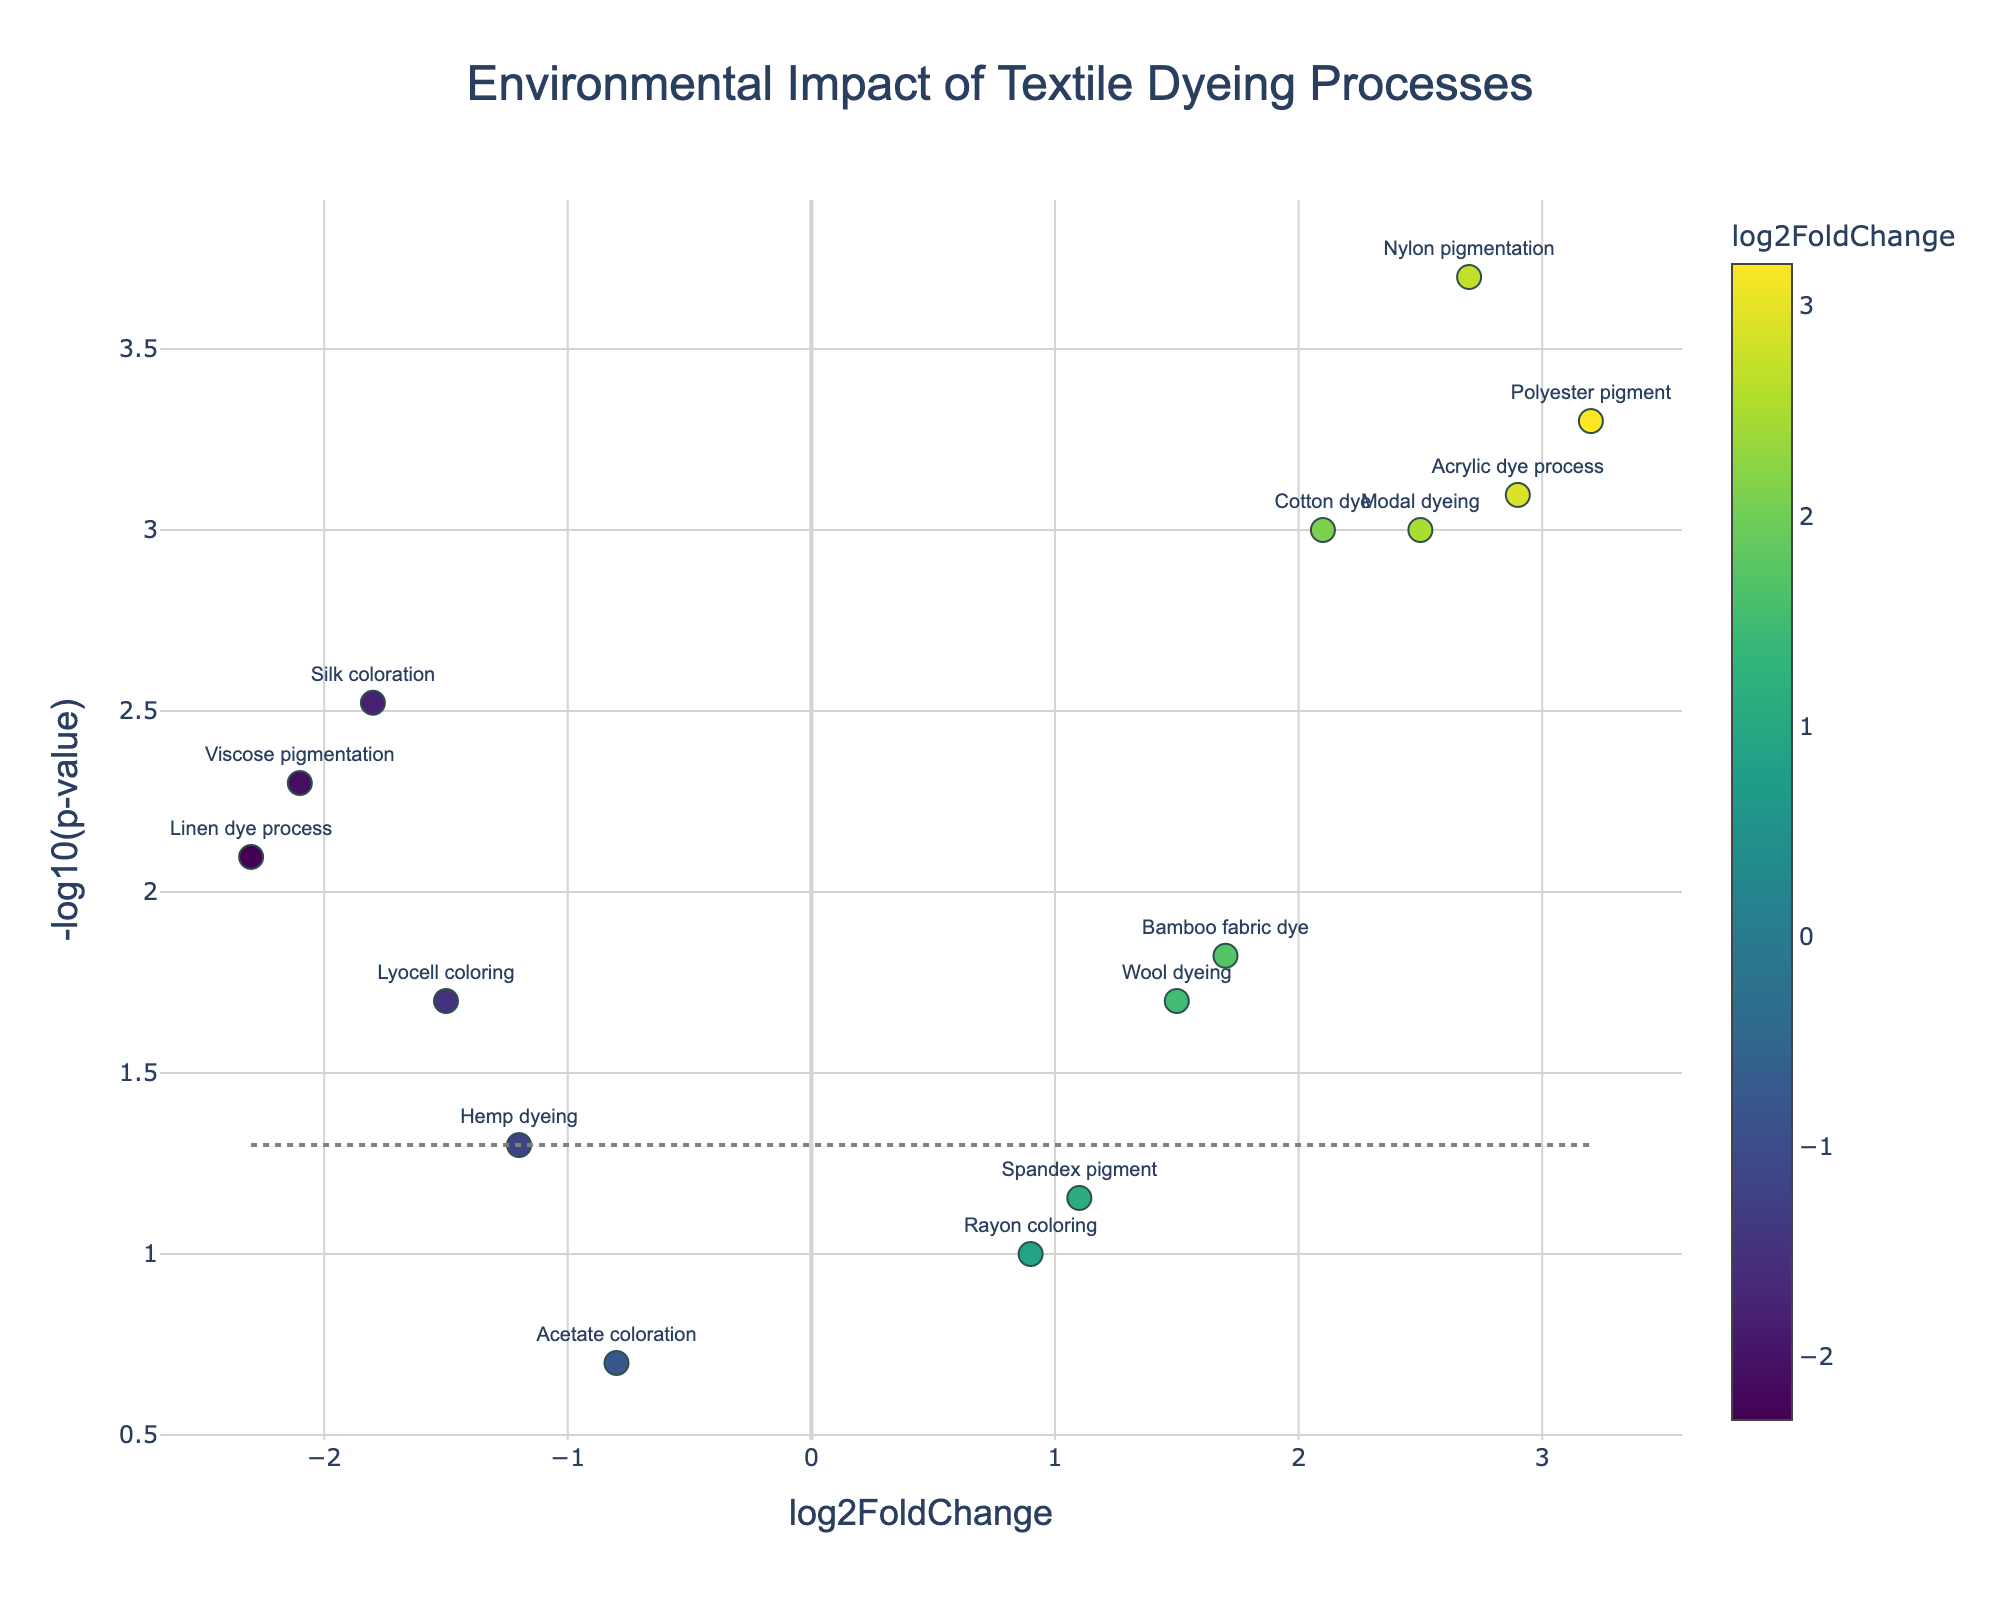What is the title of the plot? The title of the plot is prominently shown at the top and reads "Environmental Impact of Textile Dyeing Processes".
Answer: Environmental Impact of Textile Dyeing Processes Which textile dyeing process has the highest log2FoldChange? To determine the highest log2FoldChange, look for the data point furthest to the right on the x-axis as this axis represents log2FoldChange. This point is labeled "Polyester pigment".
Answer: Polyester pigment Which textile dyeing process has the lowest p-value? The p-value can be inferred from the y-axis, which represents -log10(p-value). The higher the y-value, the lower the p-value. Therefore, the highest y-value represents the lowest p-value and it corresponds to "Nylon pigmentation".
Answer: Nylon pigmentation How many textile dyeing processes have a p-value lower than 0.05? The horizontal line in the plot represents the threshold for a p-value of 0.05. We count the number of points above this line. There are nine points above this line.
Answer: 9 Which textile dyeing process has the lowest log2FoldChange? To find the lowest log2FoldChange, look at the data point furthest to the left on the x-axis. This point is labeled "Linen dye process".
Answer: Linen dye process What is the y-axis label of the plot? The y-axis represents the negative logarithm of the p-value; hence, the label is "-log10(p-value)".
Answer: -log10(p-value) Among Cotton dye and Silk coloration, which has a more significant p-value? Silk coloration has a lower y-value than Cotton dye on the plot, implying a higher p-value since it has a less negative log10 transformation. Therefore, Silk coloration has a more significant (higher) p-value.
Answer: Silk coloration Is there a textile dyeing process with both a log2FoldChange greater than 2 and a p-value less than 0.001? Looking at the data points with log2FoldChange values greater than 2 on the x-axis and checking if their corresponding y-axis values ( -log10(p-value)) are above 3 (since -log10(0.001) = 3), we find "Polyester pigment", "Nylon pigmentation", and "Acrylic dye process" satisfy these conditions.
Answer: Yes What do the colors of the data points represent? The color of the data points represents the log2FoldChange values. The color scale is shown on the right side of the plot.
Answer: log2FoldChange Among all the textile dyeing processes with a negative log2FoldChange, which has the smallest p-value and what is their -log10(p-value)? Among the points with negative log2FoldChange, locate the one with the highest y-axis value, which corresponds to the smallest p-value. "Viscose pigmentation" has the highest y-value among negative log2FoldChange, and its -log10(p-value) is around 2.3.
Answer: Viscose pigmentation, 2.3 